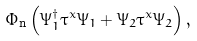Convert formula to latex. <formula><loc_0><loc_0><loc_500><loc_500>\Phi _ { \text {n} } \left ( \Psi _ { 1 } ^ { \dagger } \tau ^ { x } \Psi _ { 1 } + \Psi _ { 2 } \tau ^ { x } \Psi _ { 2 } \right ) ,</formula> 